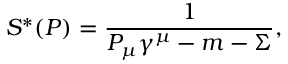<formula> <loc_0><loc_0><loc_500><loc_500>S ^ { * } ( P ) = \frac { 1 } { P _ { \mu } \gamma ^ { \mu } - m - \Sigma } ,</formula> 